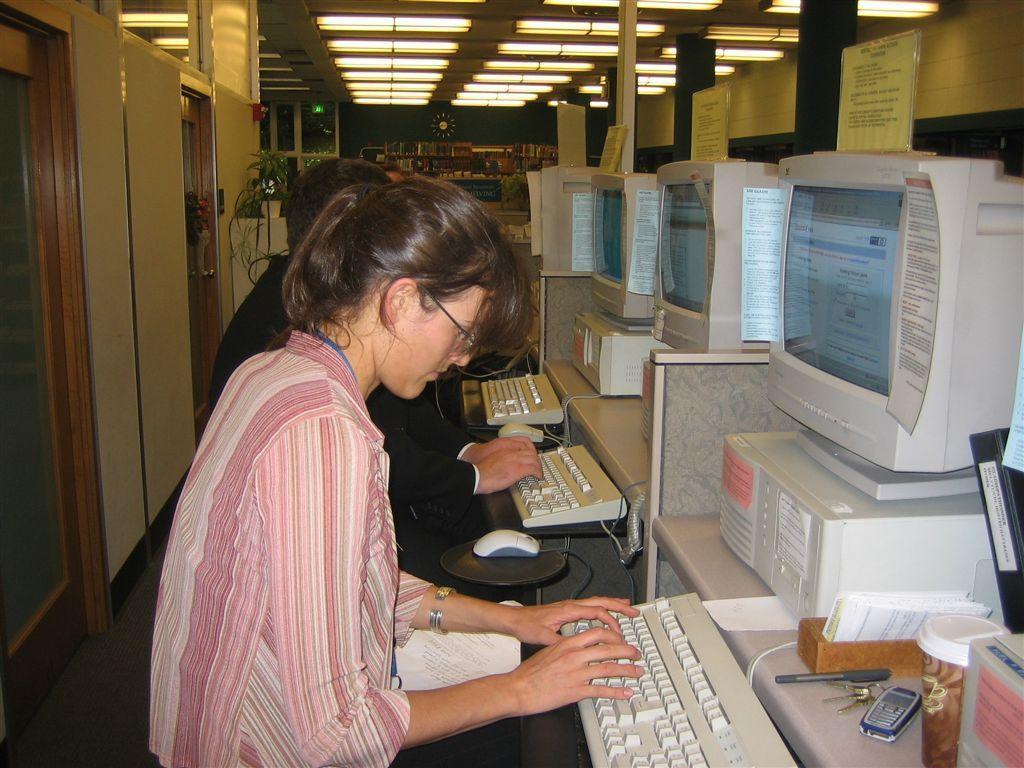How would you summarize this image in a sentence or two? In this picture we can see few people, they are sitting on the chairs, in front of them we can see keyboards, mouse, monitors, mobile and other things on the tables, in the background we can find few lights and notice boards. 